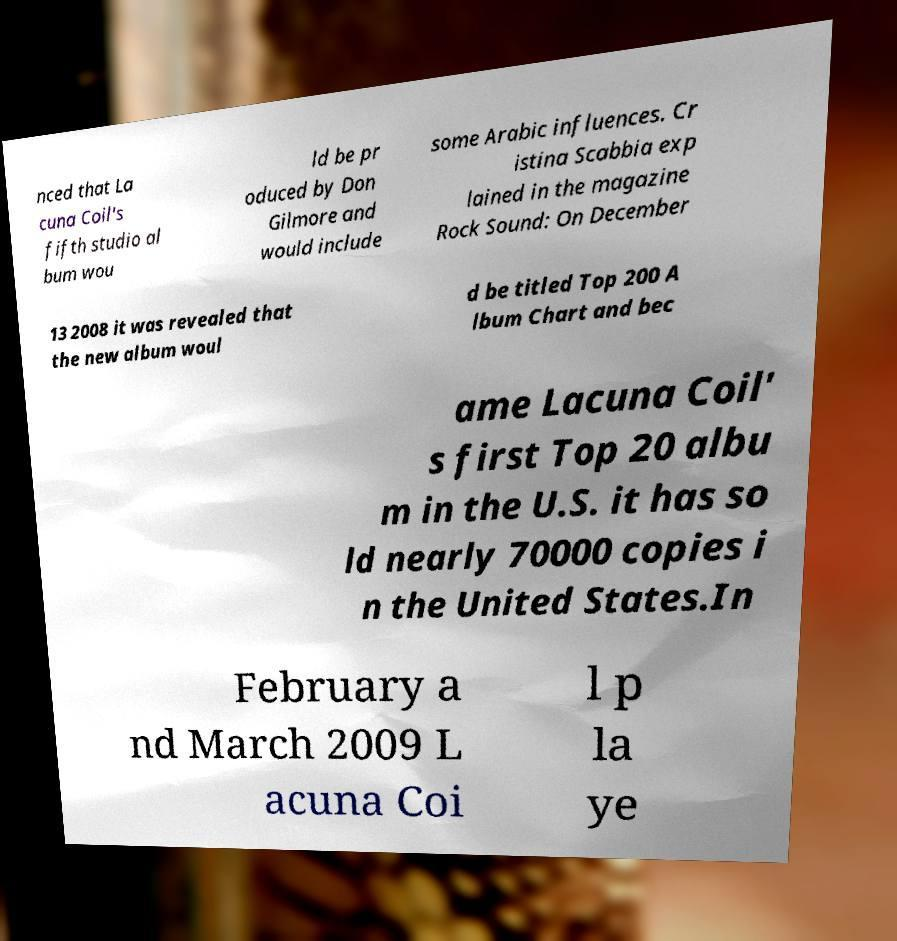Can you accurately transcribe the text from the provided image for me? nced that La cuna Coil's fifth studio al bum wou ld be pr oduced by Don Gilmore and would include some Arabic influences. Cr istina Scabbia exp lained in the magazine Rock Sound: On December 13 2008 it was revealed that the new album woul d be titled Top 200 A lbum Chart and bec ame Lacuna Coil' s first Top 20 albu m in the U.S. it has so ld nearly 70000 copies i n the United States.In February a nd March 2009 L acuna Coi l p la ye 